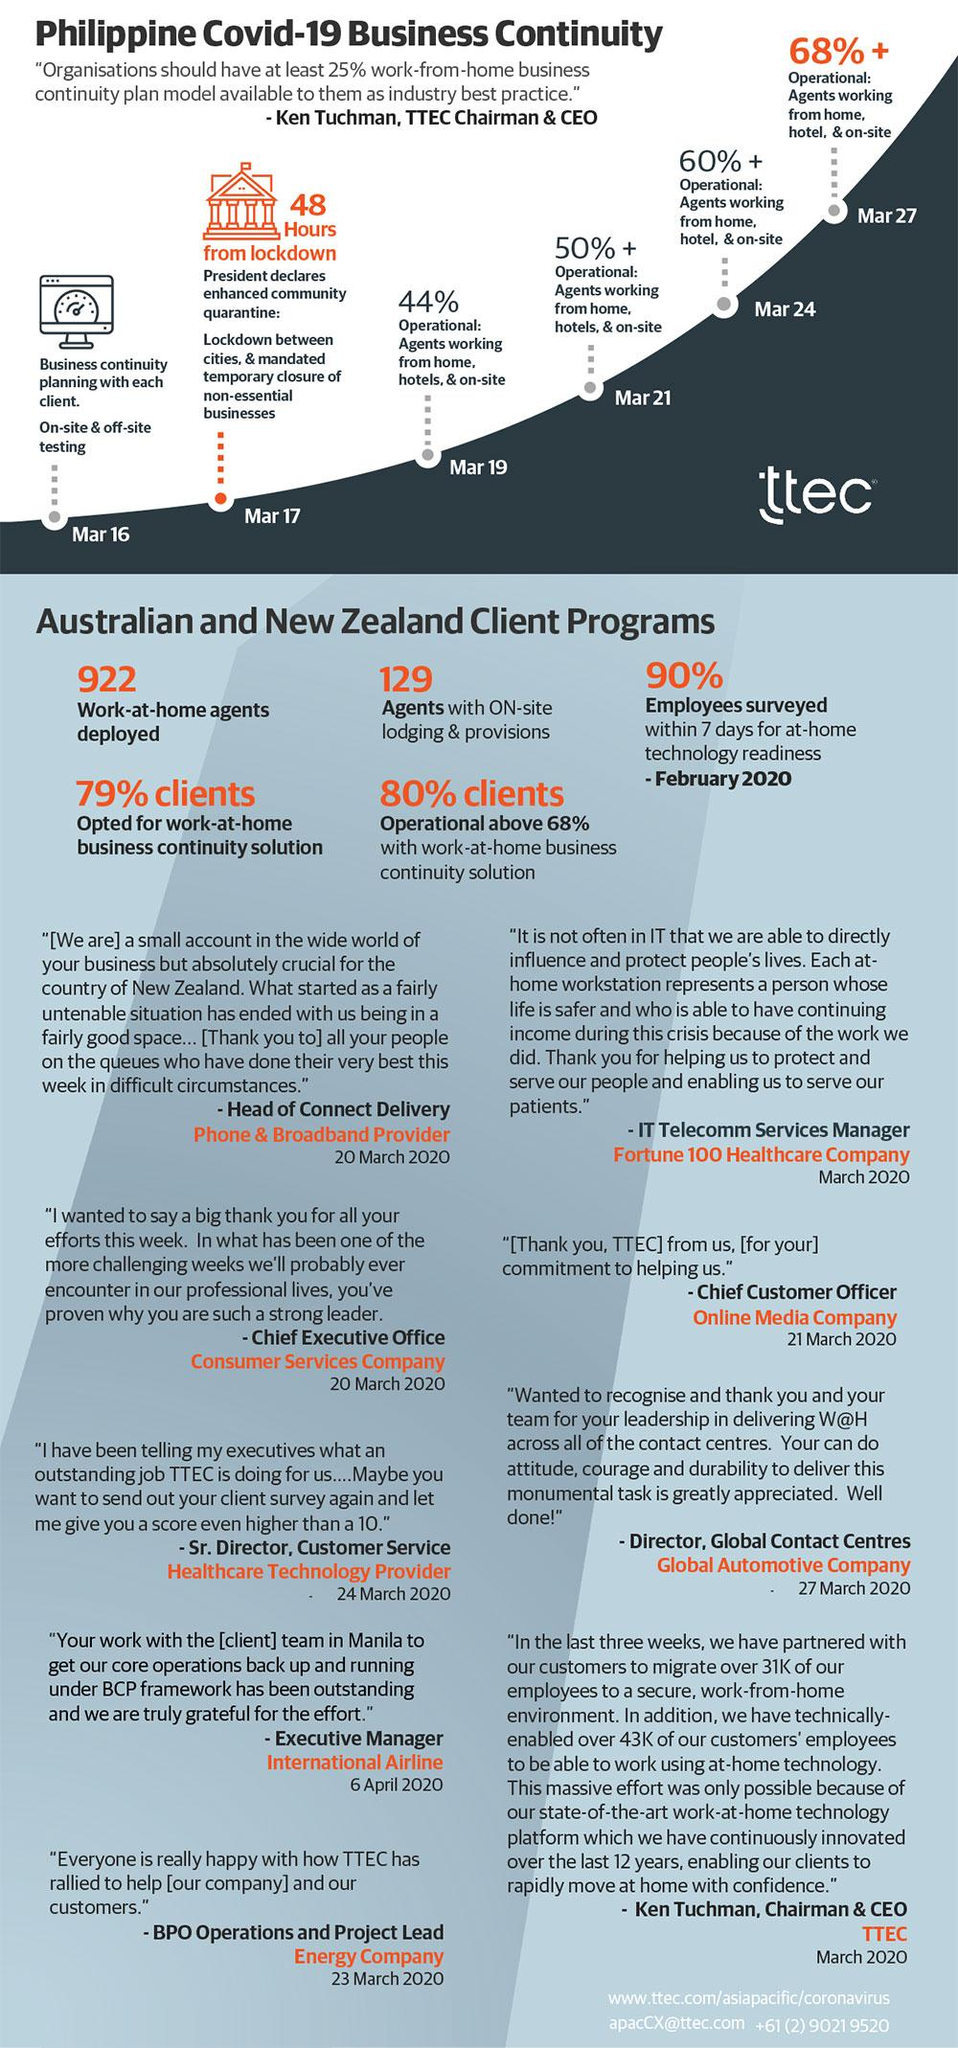Indicate a few pertinent items in this graphic. During the COVID-19 pandemic, a majority of clients in the Philippines who implemented a work-at-home business continuity solution were able to maintain operational levels above 68%. Specifically, 80% of clients achieved this level of operational readiness. The President declared a mandated temporary closure of non-essential businesses in the Philippines on March 17. During the COVID-19 pandemic, a total of 922 work-at-home agents were deployed in the Australian and New Zealand Client Programs. On March 24, there was a 60% increase in the number of agents working from home, in hotels, and on-site in the Philippines. On March 27 during the COVID-19 pandemic, there was a 68% increase in the number of agents working from home, in hotels, and on-site in the Philippines. 